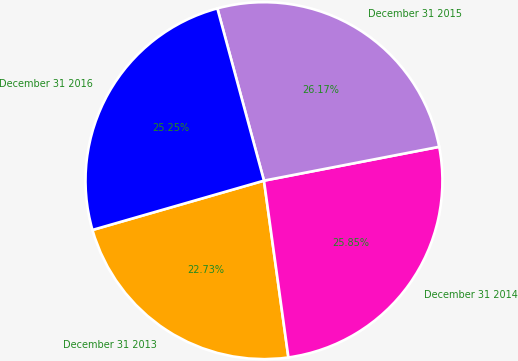Convert chart. <chart><loc_0><loc_0><loc_500><loc_500><pie_chart><fcel>December 31 2013<fcel>December 31 2014<fcel>December 31 2015<fcel>December 31 2016<nl><fcel>22.73%<fcel>25.85%<fcel>26.17%<fcel>25.25%<nl></chart> 